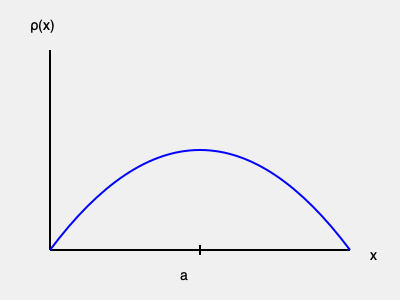Consider a one-dimensional crystal lattice with lattice constant $a$. The electron density distribution $\rho(x)$ along the x-axis is shown in the figure above. Which of the following functions best represents this electron density distribution?

A) $\rho(x) = \rho_0 \cos^2(\frac{\pi x}{a})$
B) $\rho(x) = \rho_0 \sin^2(\frac{\pi x}{a})$
C) $\rho(x) = \rho_0 |\sin(\frac{\pi x}{a})|$
D) $\rho(x) = \rho_0 |\cos(\frac{\pi x}{a})|$

Where $\rho_0$ is the maximum electron density. To determine the correct function for the electron density distribution, let's analyze the properties of the given graph and compare them with the proposed functions:

1. The function is periodic with period $a$.
2. The function has maxima at $x = 0$ and $x = a$, and a minimum at $x = a/2$.
3. The function is symmetric about $x = a/2$.
4. The function is always non-negative.

Let's evaluate each option:

A) $\rho(x) = \rho_0 \cos^2(\frac{\pi x}{a})$
   - Periodic with period $a$
   - Maxima at $x = 0$ and $x = a$, minimum at $x = a/2$
   - Symmetric about $x = a/2$
   - Always non-negative
   This function satisfies all the required properties.

B) $\rho(x) = \rho_0 \sin^2(\frac{\pi x}{a})$
   - Periodic with period $a$
   - Maximum at $x = a/2$, minima at $x = 0$ and $x = a$
   - Symmetric about $x = a/2$
   - Always non-negative
   This function does not match the graph's behavior.

C) $\rho(x) = \rho_0 |\sin(\frac{\pi x}{a})|$
   - Periodic with period $a$
   - Maximum at $x = a/2$, minima at $x = 0$ and $x = a$
   - Symmetric about $x = a/2$
   - Always non-negative
   This function does not match the graph's behavior.

D) $\rho(x) = \rho_0 |\cos(\frac{\pi x}{a})|$
   - Periodic with period $a$
   - Maxima at $x = 0$ and $x = a$, minimum at $x = a/2$
   - Symmetric about $x = a/2$
   - Always non-negative
   This function satisfies all the required properties, but it has sharp corners at $x = a/2$, which are not present in the smooth curve shown in the graph.

Therefore, the function that best represents the electron density distribution shown in the graph is option A: $\rho(x) = \rho_0 \cos^2(\frac{\pi x}{a})$.
Answer: A) $\rho(x) = \rho_0 \cos^2(\frac{\pi x}{a})$ 